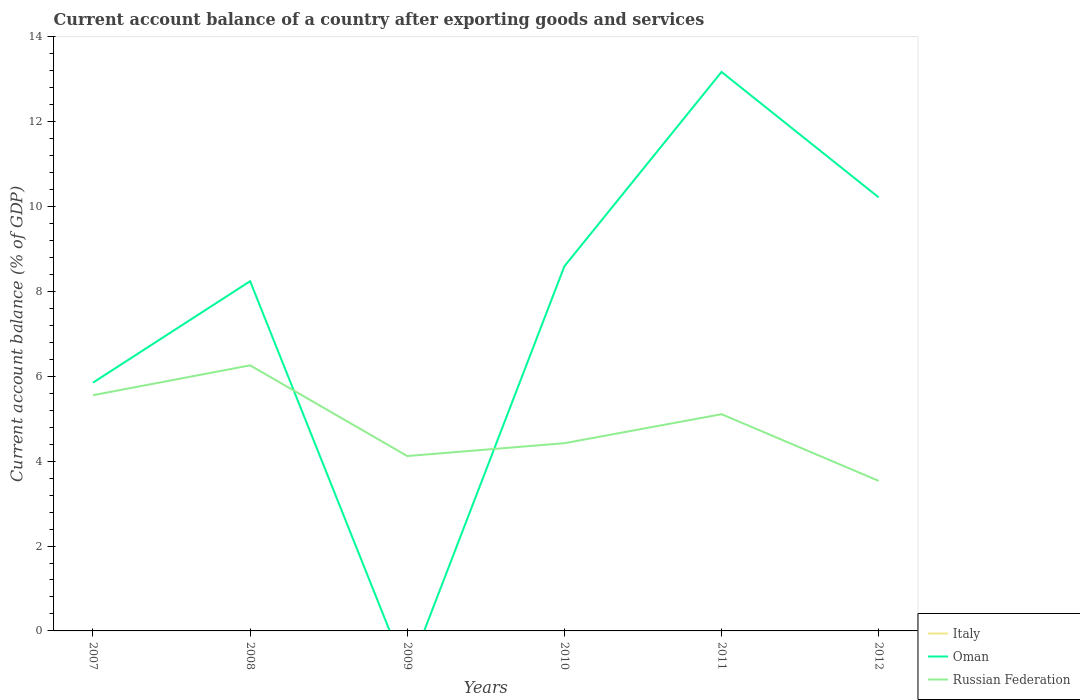How many different coloured lines are there?
Provide a short and direct response. 2. Does the line corresponding to Italy intersect with the line corresponding to Oman?
Ensure brevity in your answer.  No. Is the number of lines equal to the number of legend labels?
Ensure brevity in your answer.  No. Across all years, what is the maximum account balance in Russian Federation?
Offer a terse response. 3.54. What is the total account balance in Russian Federation in the graph?
Give a very brief answer. 2.72. What is the difference between the highest and the second highest account balance in Russian Federation?
Your answer should be very brief. 2.72. How many years are there in the graph?
Provide a succinct answer. 6. What is the difference between two consecutive major ticks on the Y-axis?
Offer a terse response. 2. Does the graph contain any zero values?
Offer a very short reply. Yes. What is the title of the graph?
Your response must be concise. Current account balance of a country after exporting goods and services. What is the label or title of the X-axis?
Make the answer very short. Years. What is the label or title of the Y-axis?
Your answer should be very brief. Current account balance (% of GDP). What is the Current account balance (% of GDP) in Italy in 2007?
Make the answer very short. 0. What is the Current account balance (% of GDP) in Oman in 2007?
Your response must be concise. 5.85. What is the Current account balance (% of GDP) in Russian Federation in 2007?
Your answer should be compact. 5.55. What is the Current account balance (% of GDP) of Oman in 2008?
Give a very brief answer. 8.24. What is the Current account balance (% of GDP) in Russian Federation in 2008?
Your answer should be very brief. 6.26. What is the Current account balance (% of GDP) in Russian Federation in 2009?
Offer a very short reply. 4.12. What is the Current account balance (% of GDP) of Oman in 2010?
Your answer should be very brief. 8.59. What is the Current account balance (% of GDP) in Russian Federation in 2010?
Give a very brief answer. 4.42. What is the Current account balance (% of GDP) of Italy in 2011?
Give a very brief answer. 0. What is the Current account balance (% of GDP) in Oman in 2011?
Offer a very short reply. 13.17. What is the Current account balance (% of GDP) in Russian Federation in 2011?
Your answer should be compact. 5.11. What is the Current account balance (% of GDP) of Italy in 2012?
Provide a succinct answer. 0. What is the Current account balance (% of GDP) in Oman in 2012?
Your answer should be compact. 10.22. What is the Current account balance (% of GDP) in Russian Federation in 2012?
Your answer should be compact. 3.54. Across all years, what is the maximum Current account balance (% of GDP) of Oman?
Offer a very short reply. 13.17. Across all years, what is the maximum Current account balance (% of GDP) of Russian Federation?
Make the answer very short. 6.26. Across all years, what is the minimum Current account balance (% of GDP) of Russian Federation?
Provide a succinct answer. 3.54. What is the total Current account balance (% of GDP) in Oman in the graph?
Provide a short and direct response. 46.07. What is the total Current account balance (% of GDP) of Russian Federation in the graph?
Your answer should be very brief. 29. What is the difference between the Current account balance (% of GDP) of Oman in 2007 and that in 2008?
Your response must be concise. -2.39. What is the difference between the Current account balance (% of GDP) of Russian Federation in 2007 and that in 2008?
Keep it short and to the point. -0.7. What is the difference between the Current account balance (% of GDP) of Russian Federation in 2007 and that in 2009?
Provide a succinct answer. 1.43. What is the difference between the Current account balance (% of GDP) of Oman in 2007 and that in 2010?
Your response must be concise. -2.74. What is the difference between the Current account balance (% of GDP) in Russian Federation in 2007 and that in 2010?
Give a very brief answer. 1.13. What is the difference between the Current account balance (% of GDP) in Oman in 2007 and that in 2011?
Ensure brevity in your answer.  -7.32. What is the difference between the Current account balance (% of GDP) of Russian Federation in 2007 and that in 2011?
Make the answer very short. 0.45. What is the difference between the Current account balance (% of GDP) of Oman in 2007 and that in 2012?
Keep it short and to the point. -4.37. What is the difference between the Current account balance (% of GDP) in Russian Federation in 2007 and that in 2012?
Provide a succinct answer. 2.02. What is the difference between the Current account balance (% of GDP) of Russian Federation in 2008 and that in 2009?
Your answer should be very brief. 2.14. What is the difference between the Current account balance (% of GDP) in Oman in 2008 and that in 2010?
Offer a very short reply. -0.35. What is the difference between the Current account balance (% of GDP) in Russian Federation in 2008 and that in 2010?
Make the answer very short. 1.83. What is the difference between the Current account balance (% of GDP) of Oman in 2008 and that in 2011?
Your response must be concise. -4.93. What is the difference between the Current account balance (% of GDP) of Russian Federation in 2008 and that in 2011?
Keep it short and to the point. 1.15. What is the difference between the Current account balance (% of GDP) of Oman in 2008 and that in 2012?
Give a very brief answer. -1.97. What is the difference between the Current account balance (% of GDP) in Russian Federation in 2008 and that in 2012?
Offer a very short reply. 2.72. What is the difference between the Current account balance (% of GDP) of Russian Federation in 2009 and that in 2010?
Offer a very short reply. -0.3. What is the difference between the Current account balance (% of GDP) of Russian Federation in 2009 and that in 2011?
Offer a very short reply. -0.99. What is the difference between the Current account balance (% of GDP) of Russian Federation in 2009 and that in 2012?
Make the answer very short. 0.59. What is the difference between the Current account balance (% of GDP) of Oman in 2010 and that in 2011?
Your answer should be very brief. -4.58. What is the difference between the Current account balance (% of GDP) of Russian Federation in 2010 and that in 2011?
Offer a very short reply. -0.68. What is the difference between the Current account balance (% of GDP) in Oman in 2010 and that in 2012?
Your answer should be very brief. -1.62. What is the difference between the Current account balance (% of GDP) of Russian Federation in 2010 and that in 2012?
Keep it short and to the point. 0.89. What is the difference between the Current account balance (% of GDP) of Oman in 2011 and that in 2012?
Provide a succinct answer. 2.96. What is the difference between the Current account balance (% of GDP) of Russian Federation in 2011 and that in 2012?
Give a very brief answer. 1.57. What is the difference between the Current account balance (% of GDP) in Oman in 2007 and the Current account balance (% of GDP) in Russian Federation in 2008?
Ensure brevity in your answer.  -0.41. What is the difference between the Current account balance (% of GDP) of Oman in 2007 and the Current account balance (% of GDP) of Russian Federation in 2009?
Your response must be concise. 1.73. What is the difference between the Current account balance (% of GDP) in Oman in 2007 and the Current account balance (% of GDP) in Russian Federation in 2010?
Provide a short and direct response. 1.43. What is the difference between the Current account balance (% of GDP) in Oman in 2007 and the Current account balance (% of GDP) in Russian Federation in 2011?
Make the answer very short. 0.74. What is the difference between the Current account balance (% of GDP) in Oman in 2007 and the Current account balance (% of GDP) in Russian Federation in 2012?
Provide a short and direct response. 2.31. What is the difference between the Current account balance (% of GDP) in Oman in 2008 and the Current account balance (% of GDP) in Russian Federation in 2009?
Offer a very short reply. 4.12. What is the difference between the Current account balance (% of GDP) of Oman in 2008 and the Current account balance (% of GDP) of Russian Federation in 2010?
Your answer should be compact. 3.82. What is the difference between the Current account balance (% of GDP) of Oman in 2008 and the Current account balance (% of GDP) of Russian Federation in 2011?
Your answer should be very brief. 3.13. What is the difference between the Current account balance (% of GDP) in Oman in 2008 and the Current account balance (% of GDP) in Russian Federation in 2012?
Offer a terse response. 4.71. What is the difference between the Current account balance (% of GDP) of Oman in 2010 and the Current account balance (% of GDP) of Russian Federation in 2011?
Keep it short and to the point. 3.49. What is the difference between the Current account balance (% of GDP) of Oman in 2010 and the Current account balance (% of GDP) of Russian Federation in 2012?
Keep it short and to the point. 5.06. What is the difference between the Current account balance (% of GDP) in Oman in 2011 and the Current account balance (% of GDP) in Russian Federation in 2012?
Your answer should be very brief. 9.64. What is the average Current account balance (% of GDP) in Italy per year?
Offer a terse response. 0. What is the average Current account balance (% of GDP) in Oman per year?
Provide a succinct answer. 7.68. What is the average Current account balance (% of GDP) in Russian Federation per year?
Keep it short and to the point. 4.83. In the year 2007, what is the difference between the Current account balance (% of GDP) of Oman and Current account balance (% of GDP) of Russian Federation?
Your response must be concise. 0.3. In the year 2008, what is the difference between the Current account balance (% of GDP) of Oman and Current account balance (% of GDP) of Russian Federation?
Provide a succinct answer. 1.98. In the year 2010, what is the difference between the Current account balance (% of GDP) in Oman and Current account balance (% of GDP) in Russian Federation?
Your answer should be compact. 4.17. In the year 2011, what is the difference between the Current account balance (% of GDP) in Oman and Current account balance (% of GDP) in Russian Federation?
Your answer should be very brief. 8.07. In the year 2012, what is the difference between the Current account balance (% of GDP) of Oman and Current account balance (% of GDP) of Russian Federation?
Offer a terse response. 6.68. What is the ratio of the Current account balance (% of GDP) of Oman in 2007 to that in 2008?
Your answer should be compact. 0.71. What is the ratio of the Current account balance (% of GDP) of Russian Federation in 2007 to that in 2008?
Provide a succinct answer. 0.89. What is the ratio of the Current account balance (% of GDP) in Russian Federation in 2007 to that in 2009?
Your response must be concise. 1.35. What is the ratio of the Current account balance (% of GDP) of Oman in 2007 to that in 2010?
Provide a short and direct response. 0.68. What is the ratio of the Current account balance (% of GDP) in Russian Federation in 2007 to that in 2010?
Your answer should be compact. 1.26. What is the ratio of the Current account balance (% of GDP) in Oman in 2007 to that in 2011?
Provide a short and direct response. 0.44. What is the ratio of the Current account balance (% of GDP) in Russian Federation in 2007 to that in 2011?
Your answer should be compact. 1.09. What is the ratio of the Current account balance (% of GDP) in Oman in 2007 to that in 2012?
Make the answer very short. 0.57. What is the ratio of the Current account balance (% of GDP) of Russian Federation in 2007 to that in 2012?
Make the answer very short. 1.57. What is the ratio of the Current account balance (% of GDP) in Russian Federation in 2008 to that in 2009?
Give a very brief answer. 1.52. What is the ratio of the Current account balance (% of GDP) in Oman in 2008 to that in 2010?
Ensure brevity in your answer.  0.96. What is the ratio of the Current account balance (% of GDP) of Russian Federation in 2008 to that in 2010?
Your answer should be compact. 1.41. What is the ratio of the Current account balance (% of GDP) in Oman in 2008 to that in 2011?
Give a very brief answer. 0.63. What is the ratio of the Current account balance (% of GDP) in Russian Federation in 2008 to that in 2011?
Provide a short and direct response. 1.23. What is the ratio of the Current account balance (% of GDP) in Oman in 2008 to that in 2012?
Your answer should be very brief. 0.81. What is the ratio of the Current account balance (% of GDP) in Russian Federation in 2008 to that in 2012?
Provide a short and direct response. 1.77. What is the ratio of the Current account balance (% of GDP) in Russian Federation in 2009 to that in 2010?
Your answer should be compact. 0.93. What is the ratio of the Current account balance (% of GDP) of Russian Federation in 2009 to that in 2011?
Give a very brief answer. 0.81. What is the ratio of the Current account balance (% of GDP) in Russian Federation in 2009 to that in 2012?
Keep it short and to the point. 1.17. What is the ratio of the Current account balance (% of GDP) in Oman in 2010 to that in 2011?
Provide a short and direct response. 0.65. What is the ratio of the Current account balance (% of GDP) of Russian Federation in 2010 to that in 2011?
Your response must be concise. 0.87. What is the ratio of the Current account balance (% of GDP) in Oman in 2010 to that in 2012?
Make the answer very short. 0.84. What is the ratio of the Current account balance (% of GDP) in Russian Federation in 2010 to that in 2012?
Offer a terse response. 1.25. What is the ratio of the Current account balance (% of GDP) in Oman in 2011 to that in 2012?
Give a very brief answer. 1.29. What is the ratio of the Current account balance (% of GDP) of Russian Federation in 2011 to that in 2012?
Offer a terse response. 1.44. What is the difference between the highest and the second highest Current account balance (% of GDP) of Oman?
Ensure brevity in your answer.  2.96. What is the difference between the highest and the second highest Current account balance (% of GDP) of Russian Federation?
Your response must be concise. 0.7. What is the difference between the highest and the lowest Current account balance (% of GDP) in Oman?
Provide a short and direct response. 13.17. What is the difference between the highest and the lowest Current account balance (% of GDP) in Russian Federation?
Give a very brief answer. 2.72. 